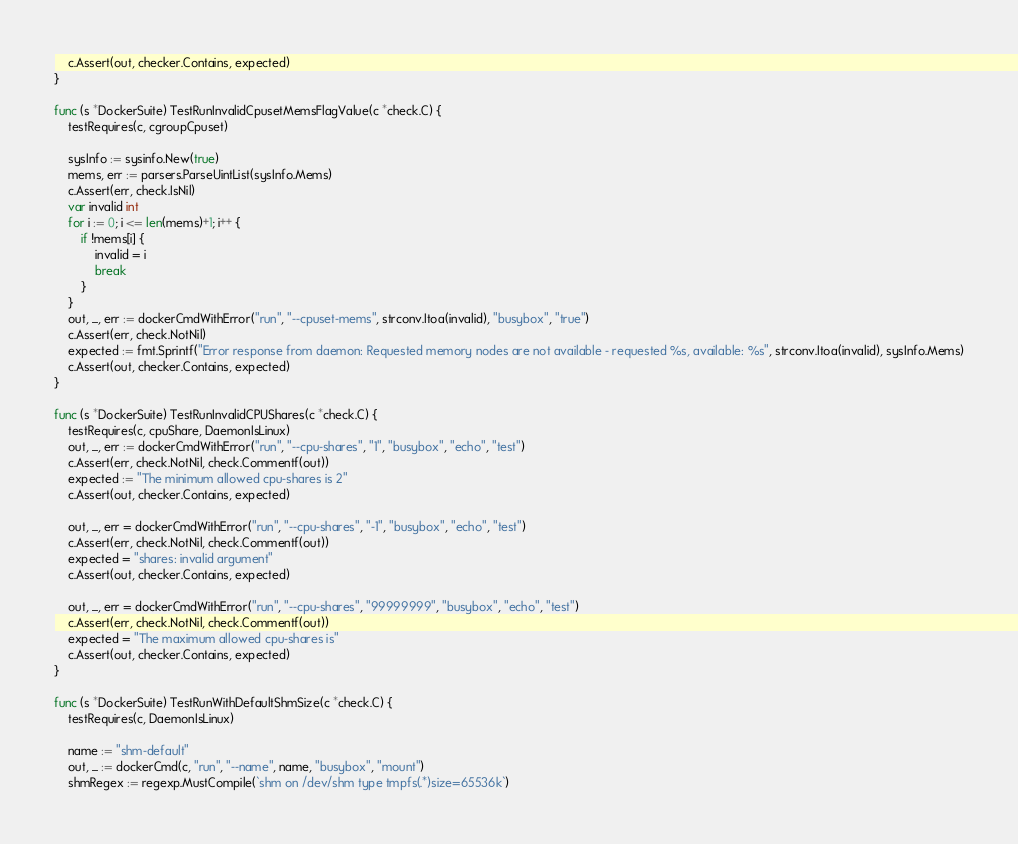<code> <loc_0><loc_0><loc_500><loc_500><_Go_>	c.Assert(out, checker.Contains, expected)
}

func (s *DockerSuite) TestRunInvalidCpusetMemsFlagValue(c *check.C) {
	testRequires(c, cgroupCpuset)

	sysInfo := sysinfo.New(true)
	mems, err := parsers.ParseUintList(sysInfo.Mems)
	c.Assert(err, check.IsNil)
	var invalid int
	for i := 0; i <= len(mems)+1; i++ {
		if !mems[i] {
			invalid = i
			break
		}
	}
	out, _, err := dockerCmdWithError("run", "--cpuset-mems", strconv.Itoa(invalid), "busybox", "true")
	c.Assert(err, check.NotNil)
	expected := fmt.Sprintf("Error response from daemon: Requested memory nodes are not available - requested %s, available: %s", strconv.Itoa(invalid), sysInfo.Mems)
	c.Assert(out, checker.Contains, expected)
}

func (s *DockerSuite) TestRunInvalidCPUShares(c *check.C) {
	testRequires(c, cpuShare, DaemonIsLinux)
	out, _, err := dockerCmdWithError("run", "--cpu-shares", "1", "busybox", "echo", "test")
	c.Assert(err, check.NotNil, check.Commentf(out))
	expected := "The minimum allowed cpu-shares is 2"
	c.Assert(out, checker.Contains, expected)

	out, _, err = dockerCmdWithError("run", "--cpu-shares", "-1", "busybox", "echo", "test")
	c.Assert(err, check.NotNil, check.Commentf(out))
	expected = "shares: invalid argument"
	c.Assert(out, checker.Contains, expected)

	out, _, err = dockerCmdWithError("run", "--cpu-shares", "99999999", "busybox", "echo", "test")
	c.Assert(err, check.NotNil, check.Commentf(out))
	expected = "The maximum allowed cpu-shares is"
	c.Assert(out, checker.Contains, expected)
}

func (s *DockerSuite) TestRunWithDefaultShmSize(c *check.C) {
	testRequires(c, DaemonIsLinux)

	name := "shm-default"
	out, _ := dockerCmd(c, "run", "--name", name, "busybox", "mount")
	shmRegex := regexp.MustCompile(`shm on /dev/shm type tmpfs(.*)size=65536k`)</code> 